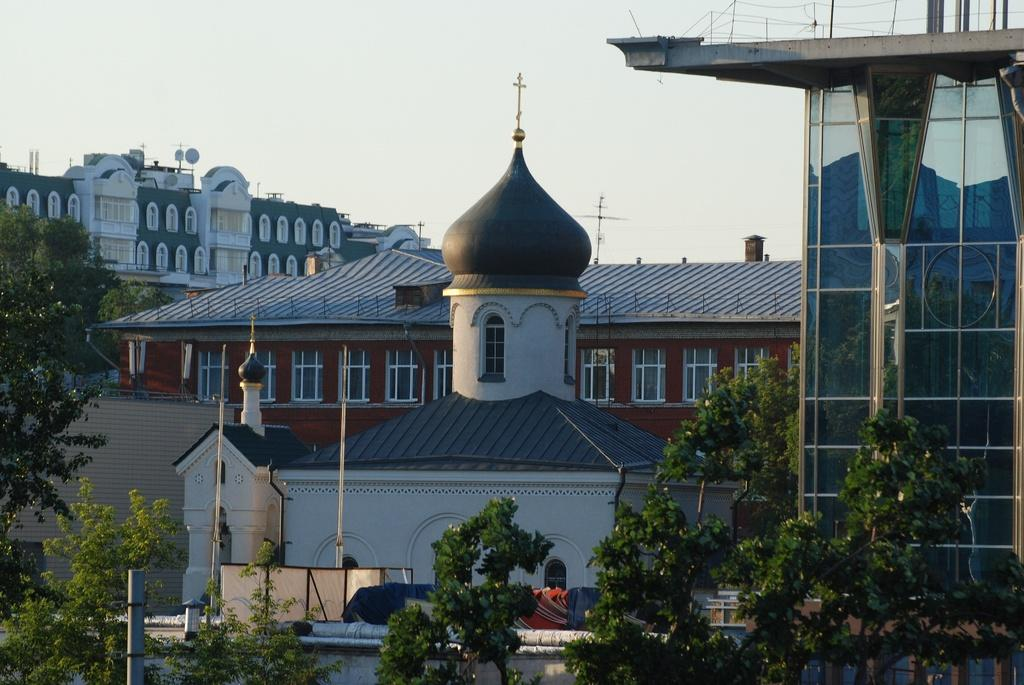What type of vegetation is in the foreground of the image? There are trees in the foreground of the image. What type of structures can be seen in the background of the image? There are buildings in the background of the image. What is the condition of the sky in the image? The sky is clear in the image. What feature is present on top of one of the buildings? There is a cross mark on top of one of the buildings. What unit of measurement is used to draw the chalk lines on the trees in the image? There are no chalk lines or measurements present on the trees in the image. Which part of the building is the cross mark located on? The cross mark is located on top of one of the buildings in the image. 